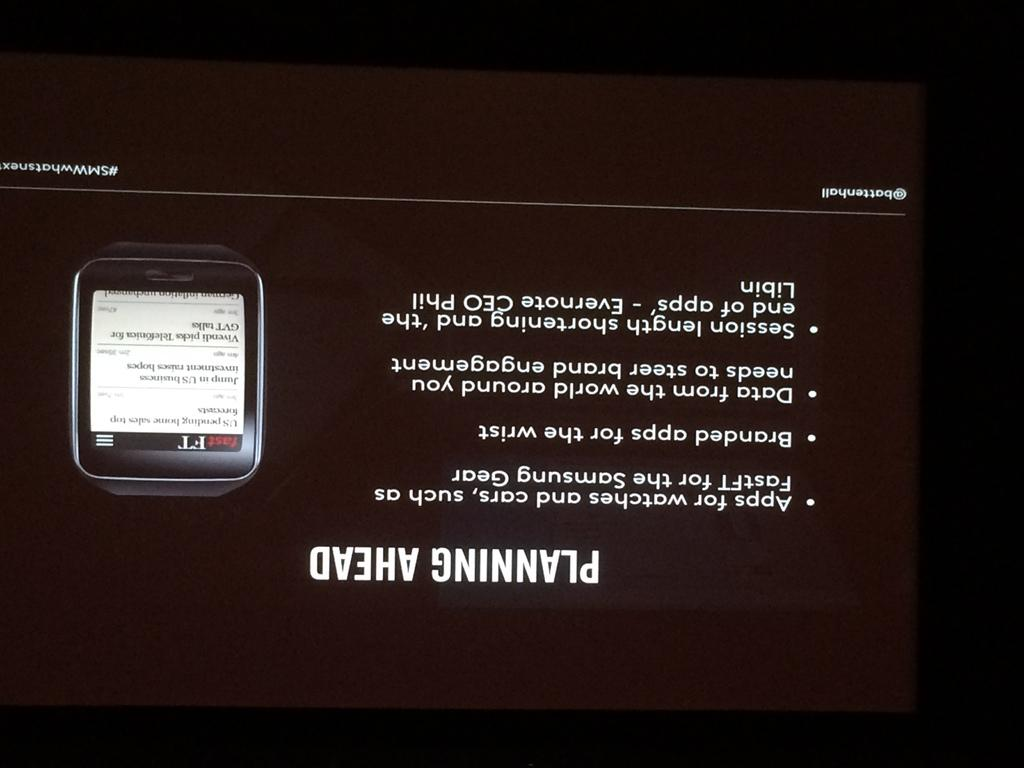<image>
Offer a succinct explanation of the picture presented. a picture sign of cell phone service to purchase 